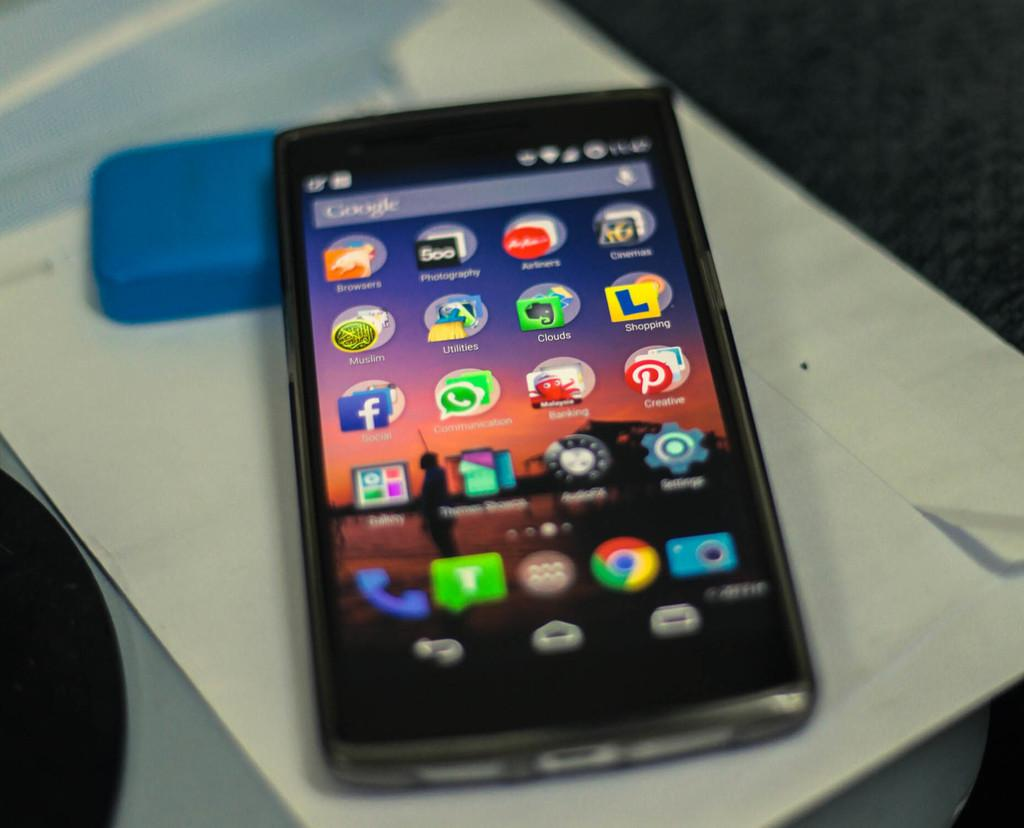What is the main object in the image? There is a mobile in the image. Where is the mobile located? The mobile is placed on a paper. What type of silver material is used to create the town in the image? There is no silver material or town present in the image; it only features a mobile placed on a paper. 